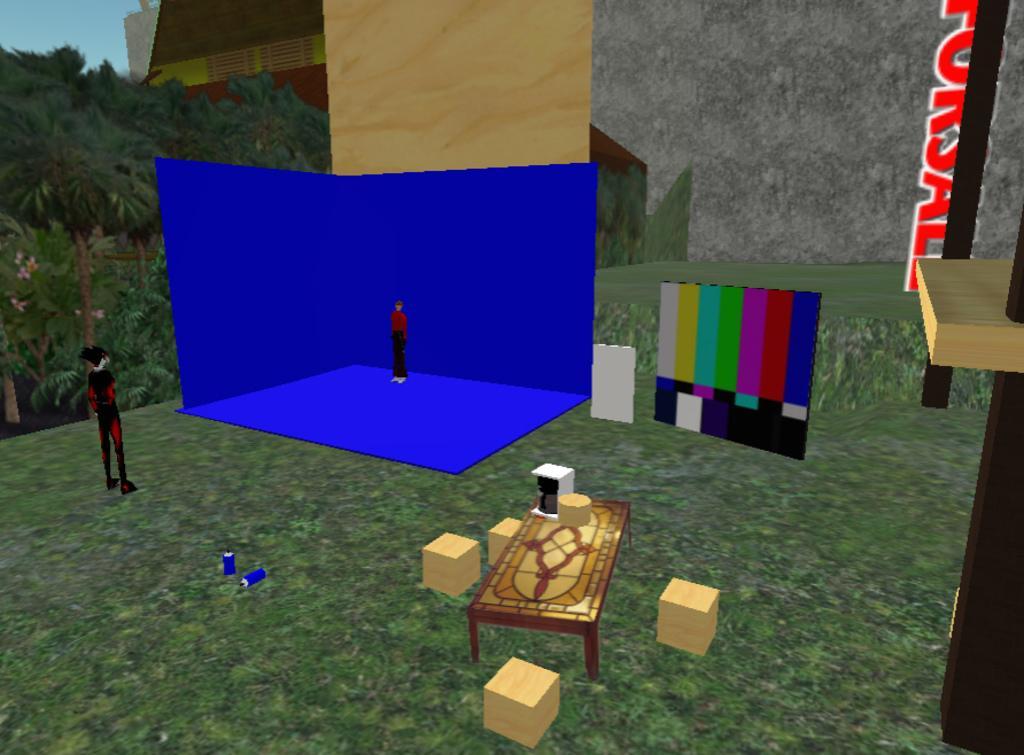How would you summarize this image in a sentence or two? This is a graphical image. Here we can see a table, blocks, persons, boards, and objects. In the background we can see trees, walls, pole, and sky. Here we can see something is written on the wall. 